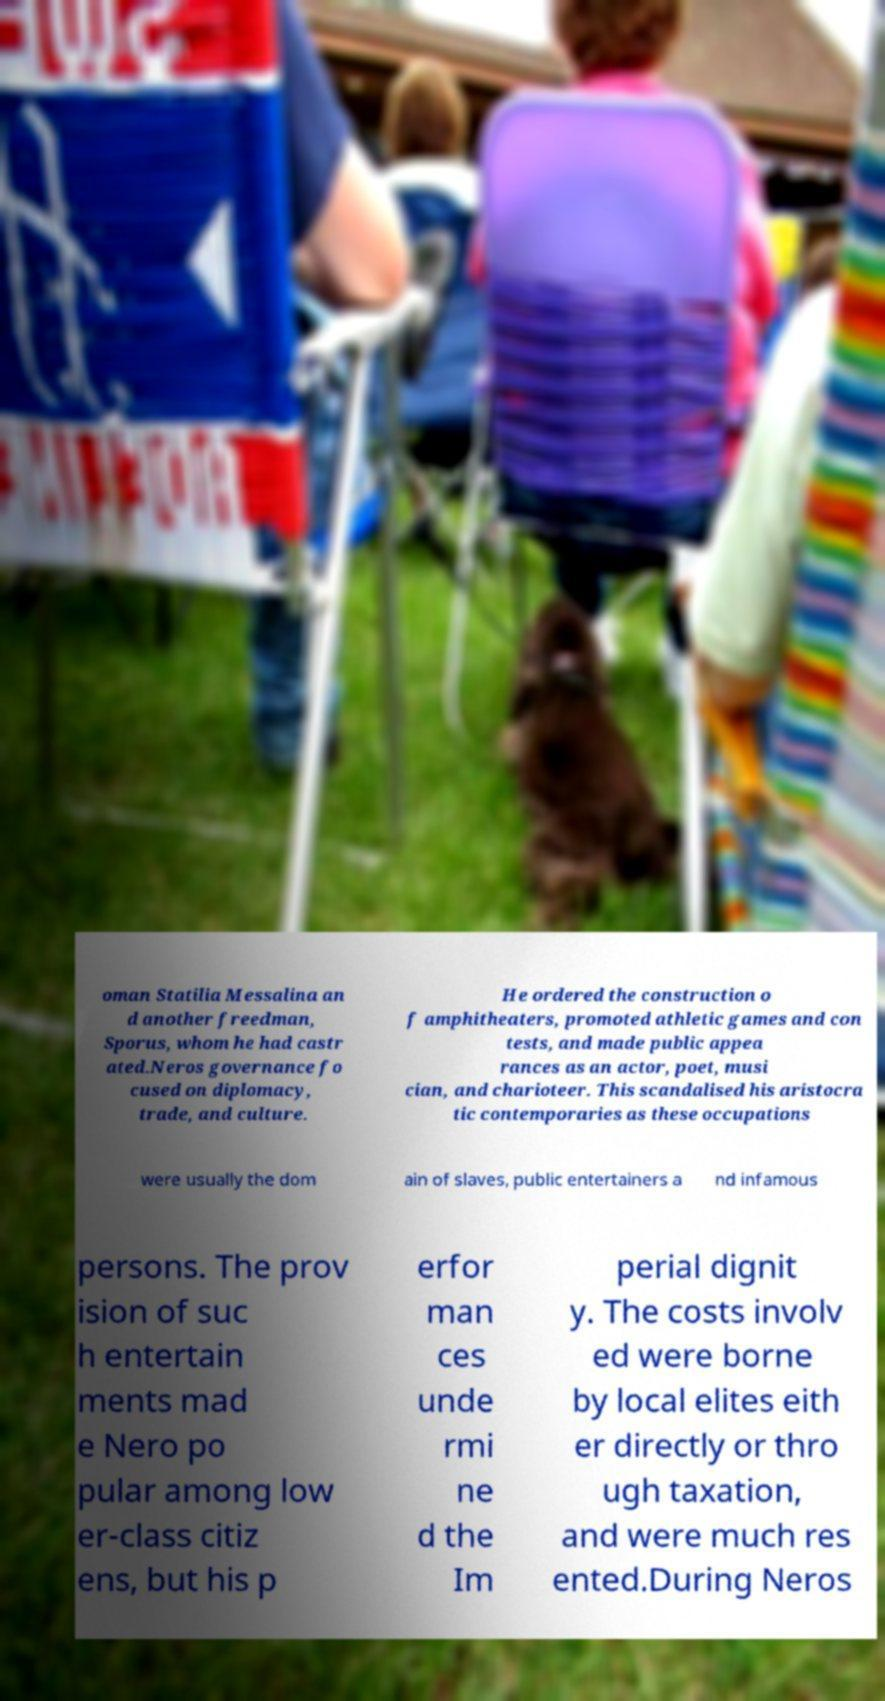Can you accurately transcribe the text from the provided image for me? oman Statilia Messalina an d another freedman, Sporus, whom he had castr ated.Neros governance fo cused on diplomacy, trade, and culture. He ordered the construction o f amphitheaters, promoted athletic games and con tests, and made public appea rances as an actor, poet, musi cian, and charioteer. This scandalised his aristocra tic contemporaries as these occupations were usually the dom ain of slaves, public entertainers a nd infamous persons. The prov ision of suc h entertain ments mad e Nero po pular among low er-class citiz ens, but his p erfor man ces unde rmi ne d the Im perial dignit y. The costs involv ed were borne by local elites eith er directly or thro ugh taxation, and were much res ented.During Neros 